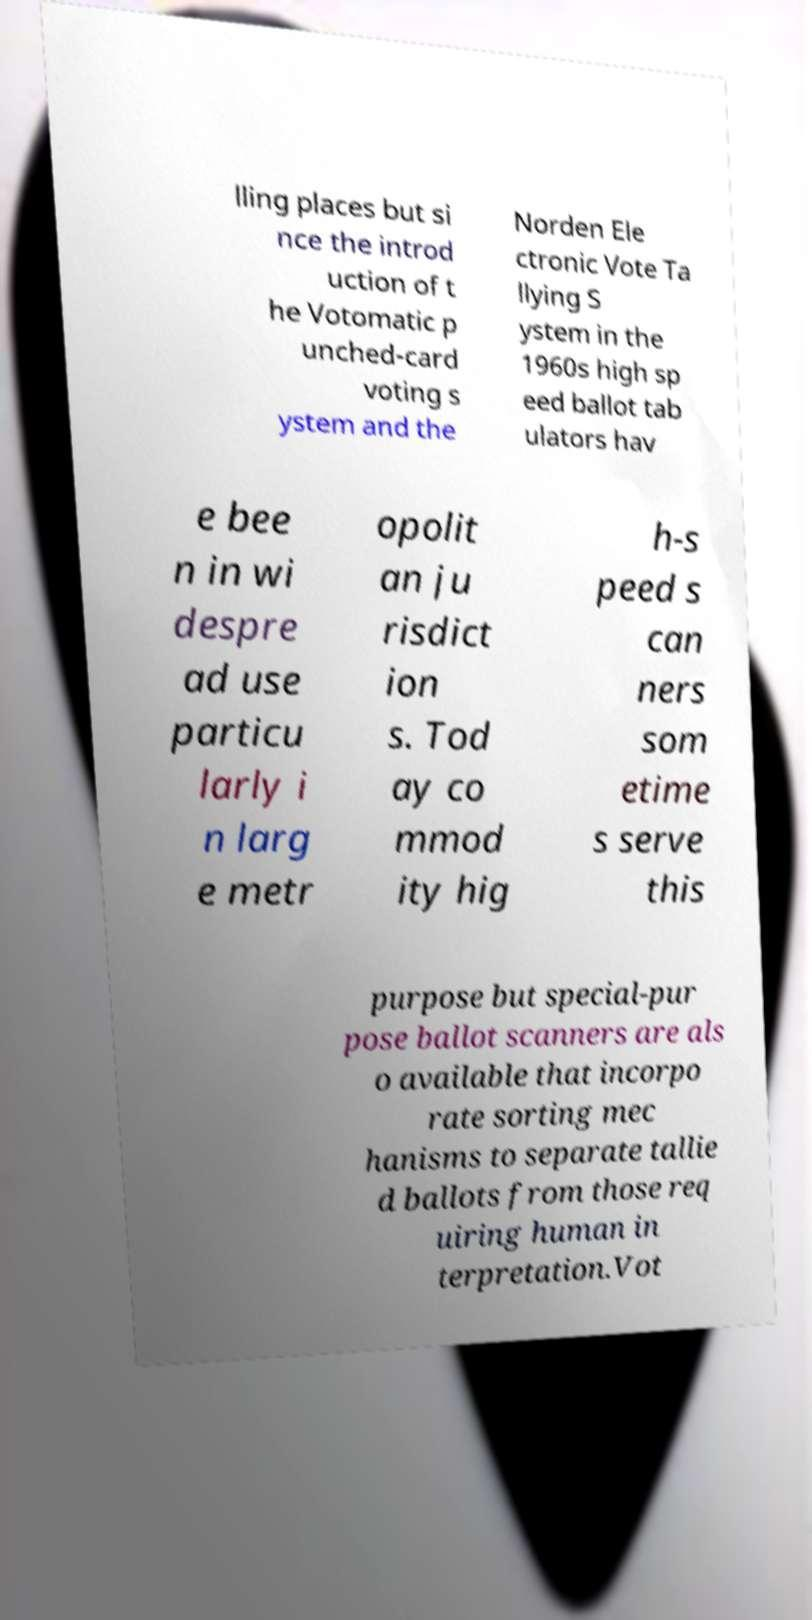There's text embedded in this image that I need extracted. Can you transcribe it verbatim? lling places but si nce the introd uction of t he Votomatic p unched-card voting s ystem and the Norden Ele ctronic Vote Ta llying S ystem in the 1960s high sp eed ballot tab ulators hav e bee n in wi despre ad use particu larly i n larg e metr opolit an ju risdict ion s. Tod ay co mmod ity hig h-s peed s can ners som etime s serve this purpose but special-pur pose ballot scanners are als o available that incorpo rate sorting mec hanisms to separate tallie d ballots from those req uiring human in terpretation.Vot 